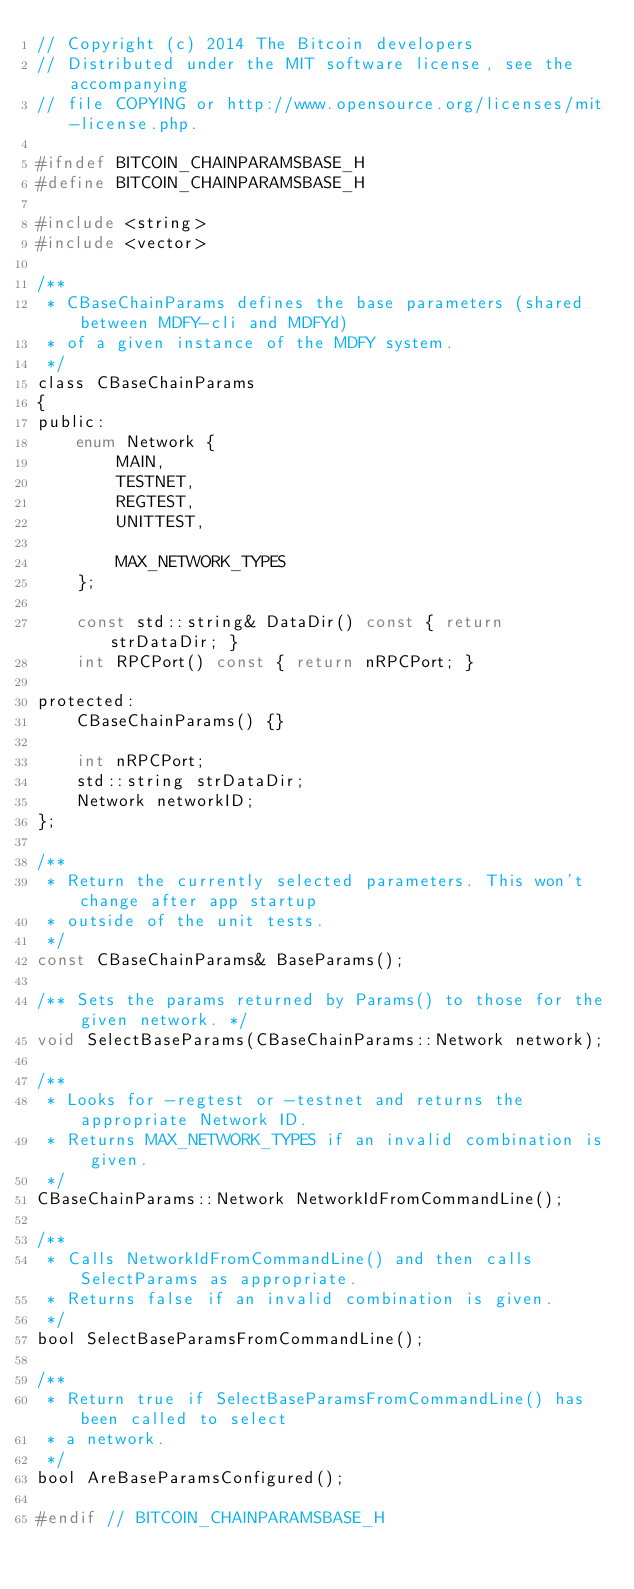<code> <loc_0><loc_0><loc_500><loc_500><_C_>// Copyright (c) 2014 The Bitcoin developers
// Distributed under the MIT software license, see the accompanying
// file COPYING or http://www.opensource.org/licenses/mit-license.php.

#ifndef BITCOIN_CHAINPARAMSBASE_H
#define BITCOIN_CHAINPARAMSBASE_H

#include <string>
#include <vector>

/**
 * CBaseChainParams defines the base parameters (shared between MDFY-cli and MDFYd)
 * of a given instance of the MDFY system.
 */
class CBaseChainParams
{
public:
    enum Network {
        MAIN,
        TESTNET,
        REGTEST,
        UNITTEST,

        MAX_NETWORK_TYPES
    };

    const std::string& DataDir() const { return strDataDir; }
    int RPCPort() const { return nRPCPort; }

protected:
    CBaseChainParams() {}

    int nRPCPort;
    std::string strDataDir;
    Network networkID;
};

/**
 * Return the currently selected parameters. This won't change after app startup
 * outside of the unit tests.
 */
const CBaseChainParams& BaseParams();

/** Sets the params returned by Params() to those for the given network. */
void SelectBaseParams(CBaseChainParams::Network network);

/**
 * Looks for -regtest or -testnet and returns the appropriate Network ID.
 * Returns MAX_NETWORK_TYPES if an invalid combination is given.
 */
CBaseChainParams::Network NetworkIdFromCommandLine();

/**
 * Calls NetworkIdFromCommandLine() and then calls SelectParams as appropriate.
 * Returns false if an invalid combination is given.
 */
bool SelectBaseParamsFromCommandLine();

/**
 * Return true if SelectBaseParamsFromCommandLine() has been called to select
 * a network.
 */
bool AreBaseParamsConfigured();

#endif // BITCOIN_CHAINPARAMSBASE_H
</code> 